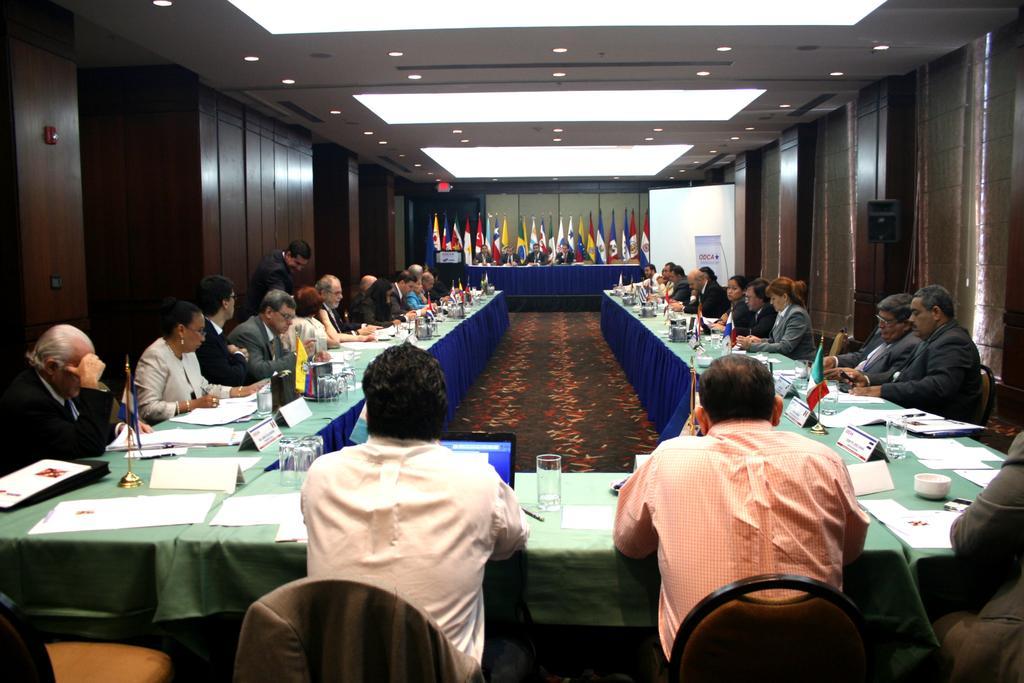Could you give a brief overview of what you see in this image? In the foreground of this image, there are persons sitting near the table on which papers, glasses, pens and a laptop. In the background, there are persons sitting near the table, flags, ceiling, and the wooden wall. 